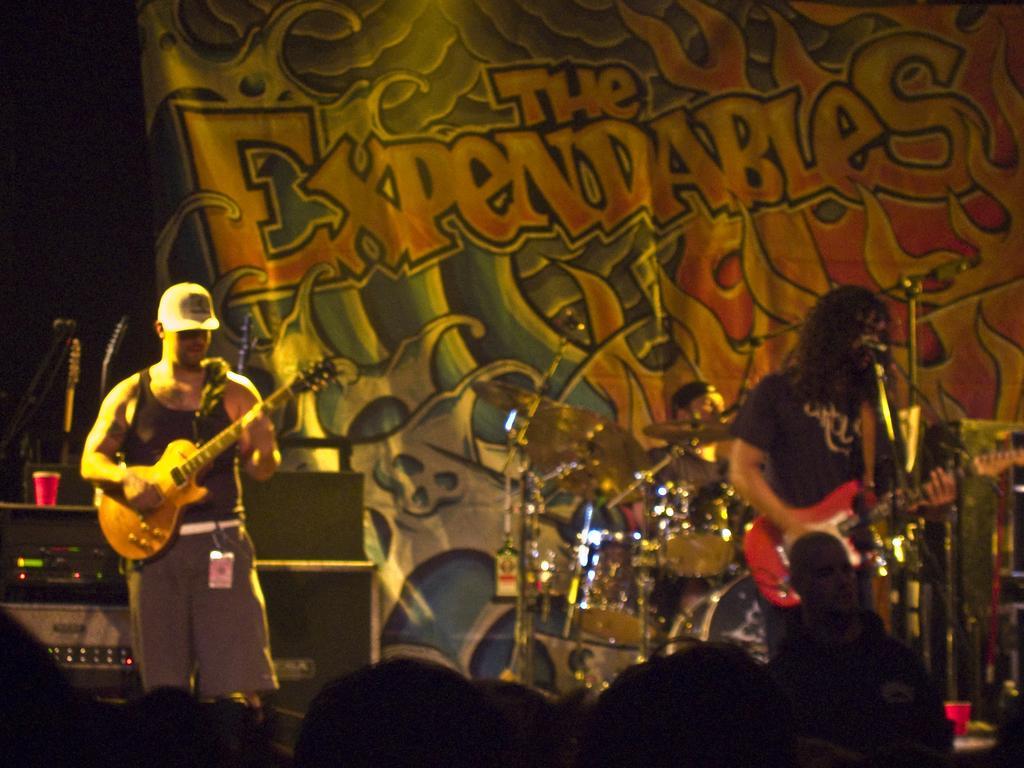In one or two sentences, can you explain what this image depicts? This picture shows two men playing guitar and we see few audience watching them. 